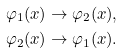<formula> <loc_0><loc_0><loc_500><loc_500>& \varphi _ { 1 } ( x ) \to \varphi _ { 2 } ( x ) , \\ & \varphi _ { 2 } ( x ) \to \varphi _ { 1 } ( x ) .</formula> 